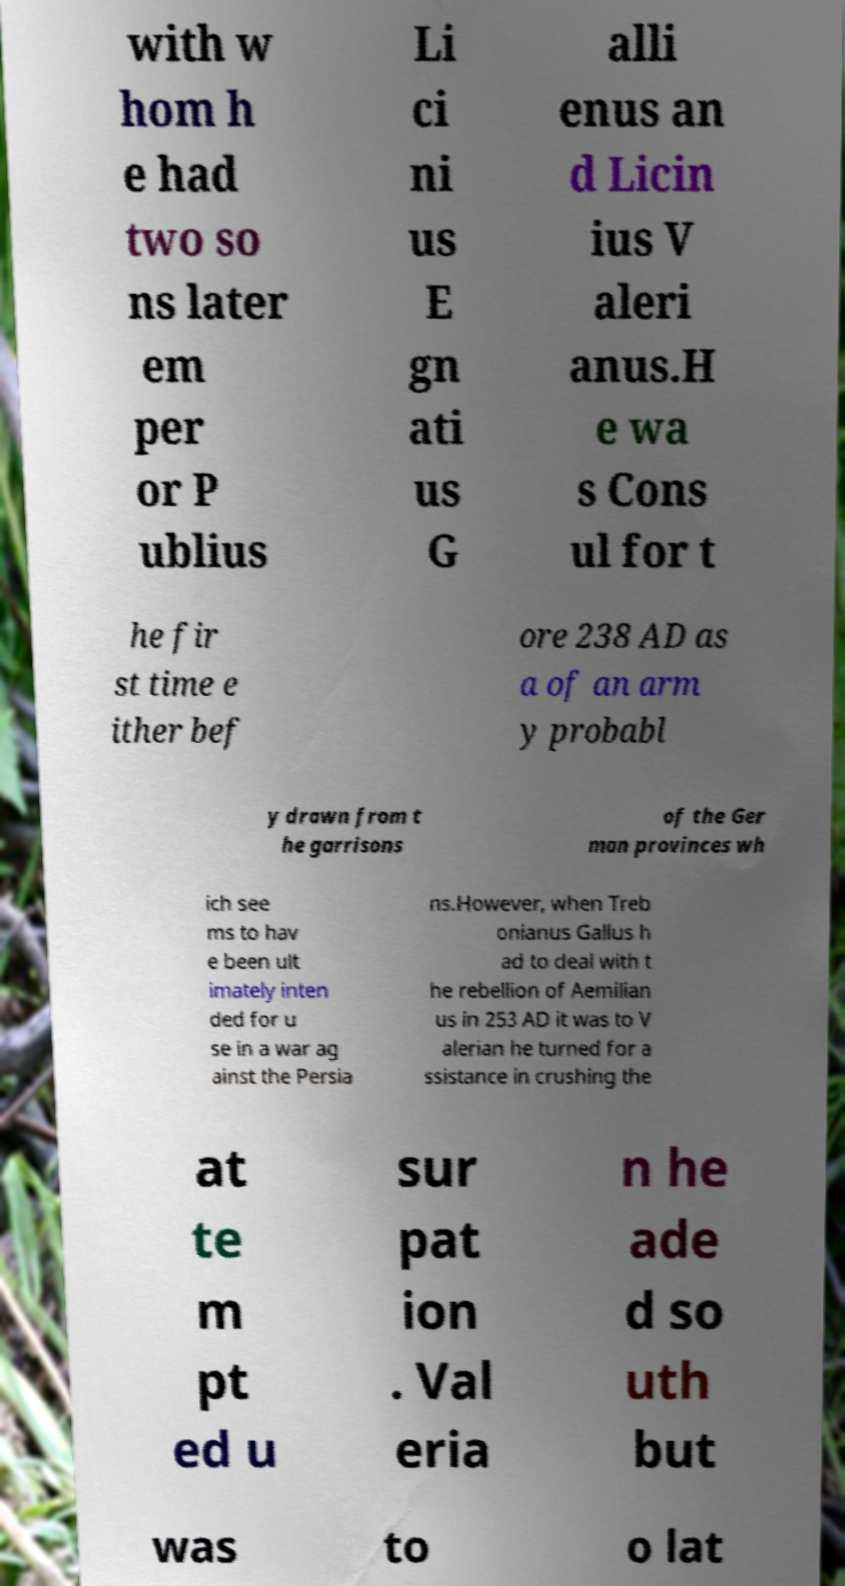Please identify and transcribe the text found in this image. with w hom h e had two so ns later em per or P ublius Li ci ni us E gn ati us G alli enus an d Licin ius V aleri anus.H e wa s Cons ul for t he fir st time e ither bef ore 238 AD as a of an arm y probabl y drawn from t he garrisons of the Ger man provinces wh ich see ms to hav e been ult imately inten ded for u se in a war ag ainst the Persia ns.However, when Treb onianus Gallus h ad to deal with t he rebellion of Aemilian us in 253 AD it was to V alerian he turned for a ssistance in crushing the at te m pt ed u sur pat ion . Val eria n he ade d so uth but was to o lat 